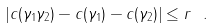<formula> <loc_0><loc_0><loc_500><loc_500>| c ( \gamma _ { 1 } \gamma _ { 2 } ) - c ( \gamma _ { 1 } ) - c ( \gamma _ { 2 } ) | \leq r \ .</formula> 